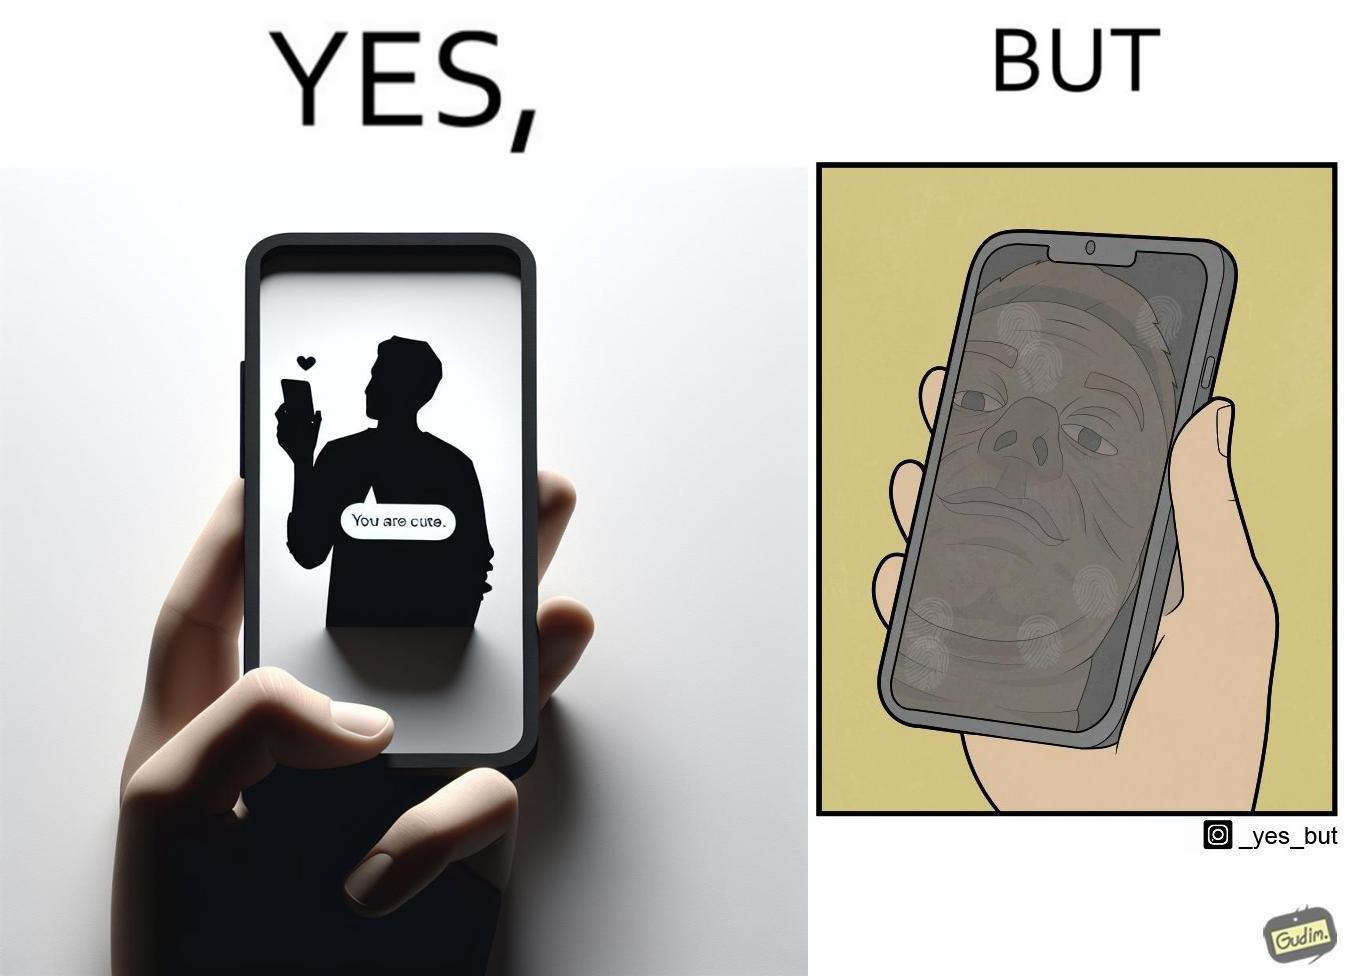What is shown in this image? The image is ironic, because person who received the text saying "you are cute" is apparently not good looking according to the beautyÃÂ standards 